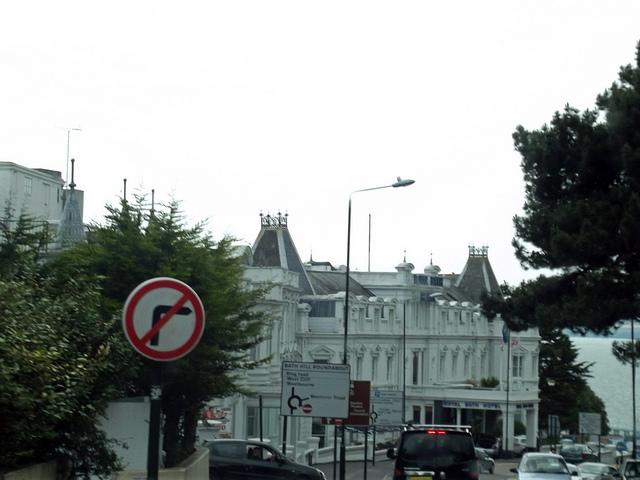What pedal does the driver of the black van have their foot on?

Choices:
A) brake
B) accelerator
C) none
D) fast forward brake 